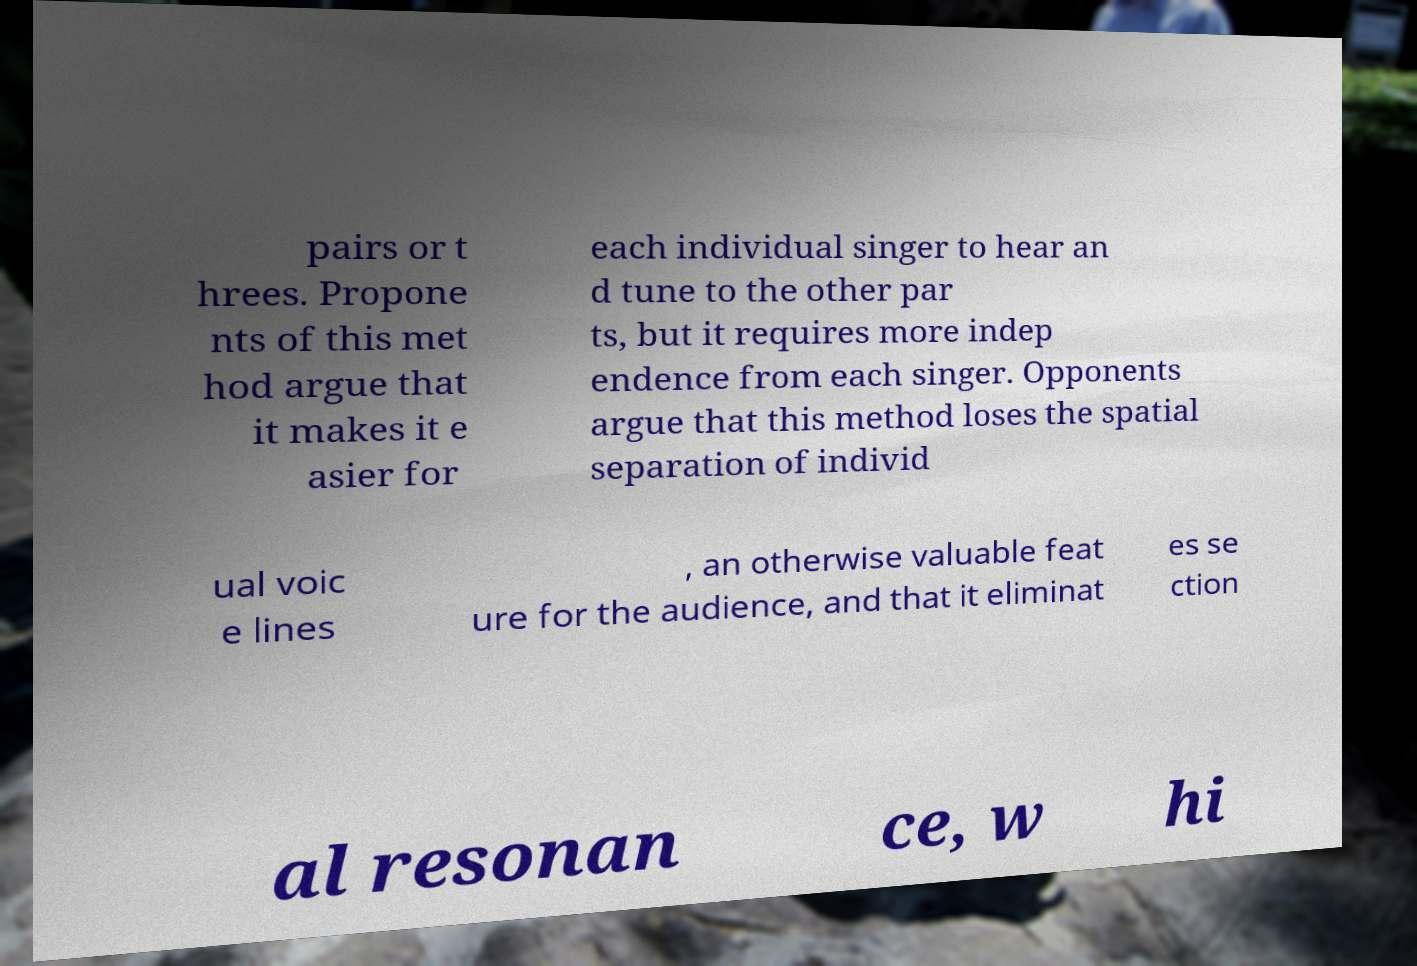What messages or text are displayed in this image? I need them in a readable, typed format. pairs or t hrees. Propone nts of this met hod argue that it makes it e asier for each individual singer to hear an d tune to the other par ts, but it requires more indep endence from each singer. Opponents argue that this method loses the spatial separation of individ ual voic e lines , an otherwise valuable feat ure for the audience, and that it eliminat es se ction al resonan ce, w hi 